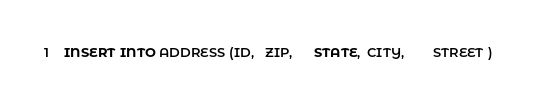<code> <loc_0><loc_0><loc_500><loc_500><_SQL_>INSERT INTO ADDRESS (ID,   ZIP,      STATE,  CITY,        STREET )</code> 